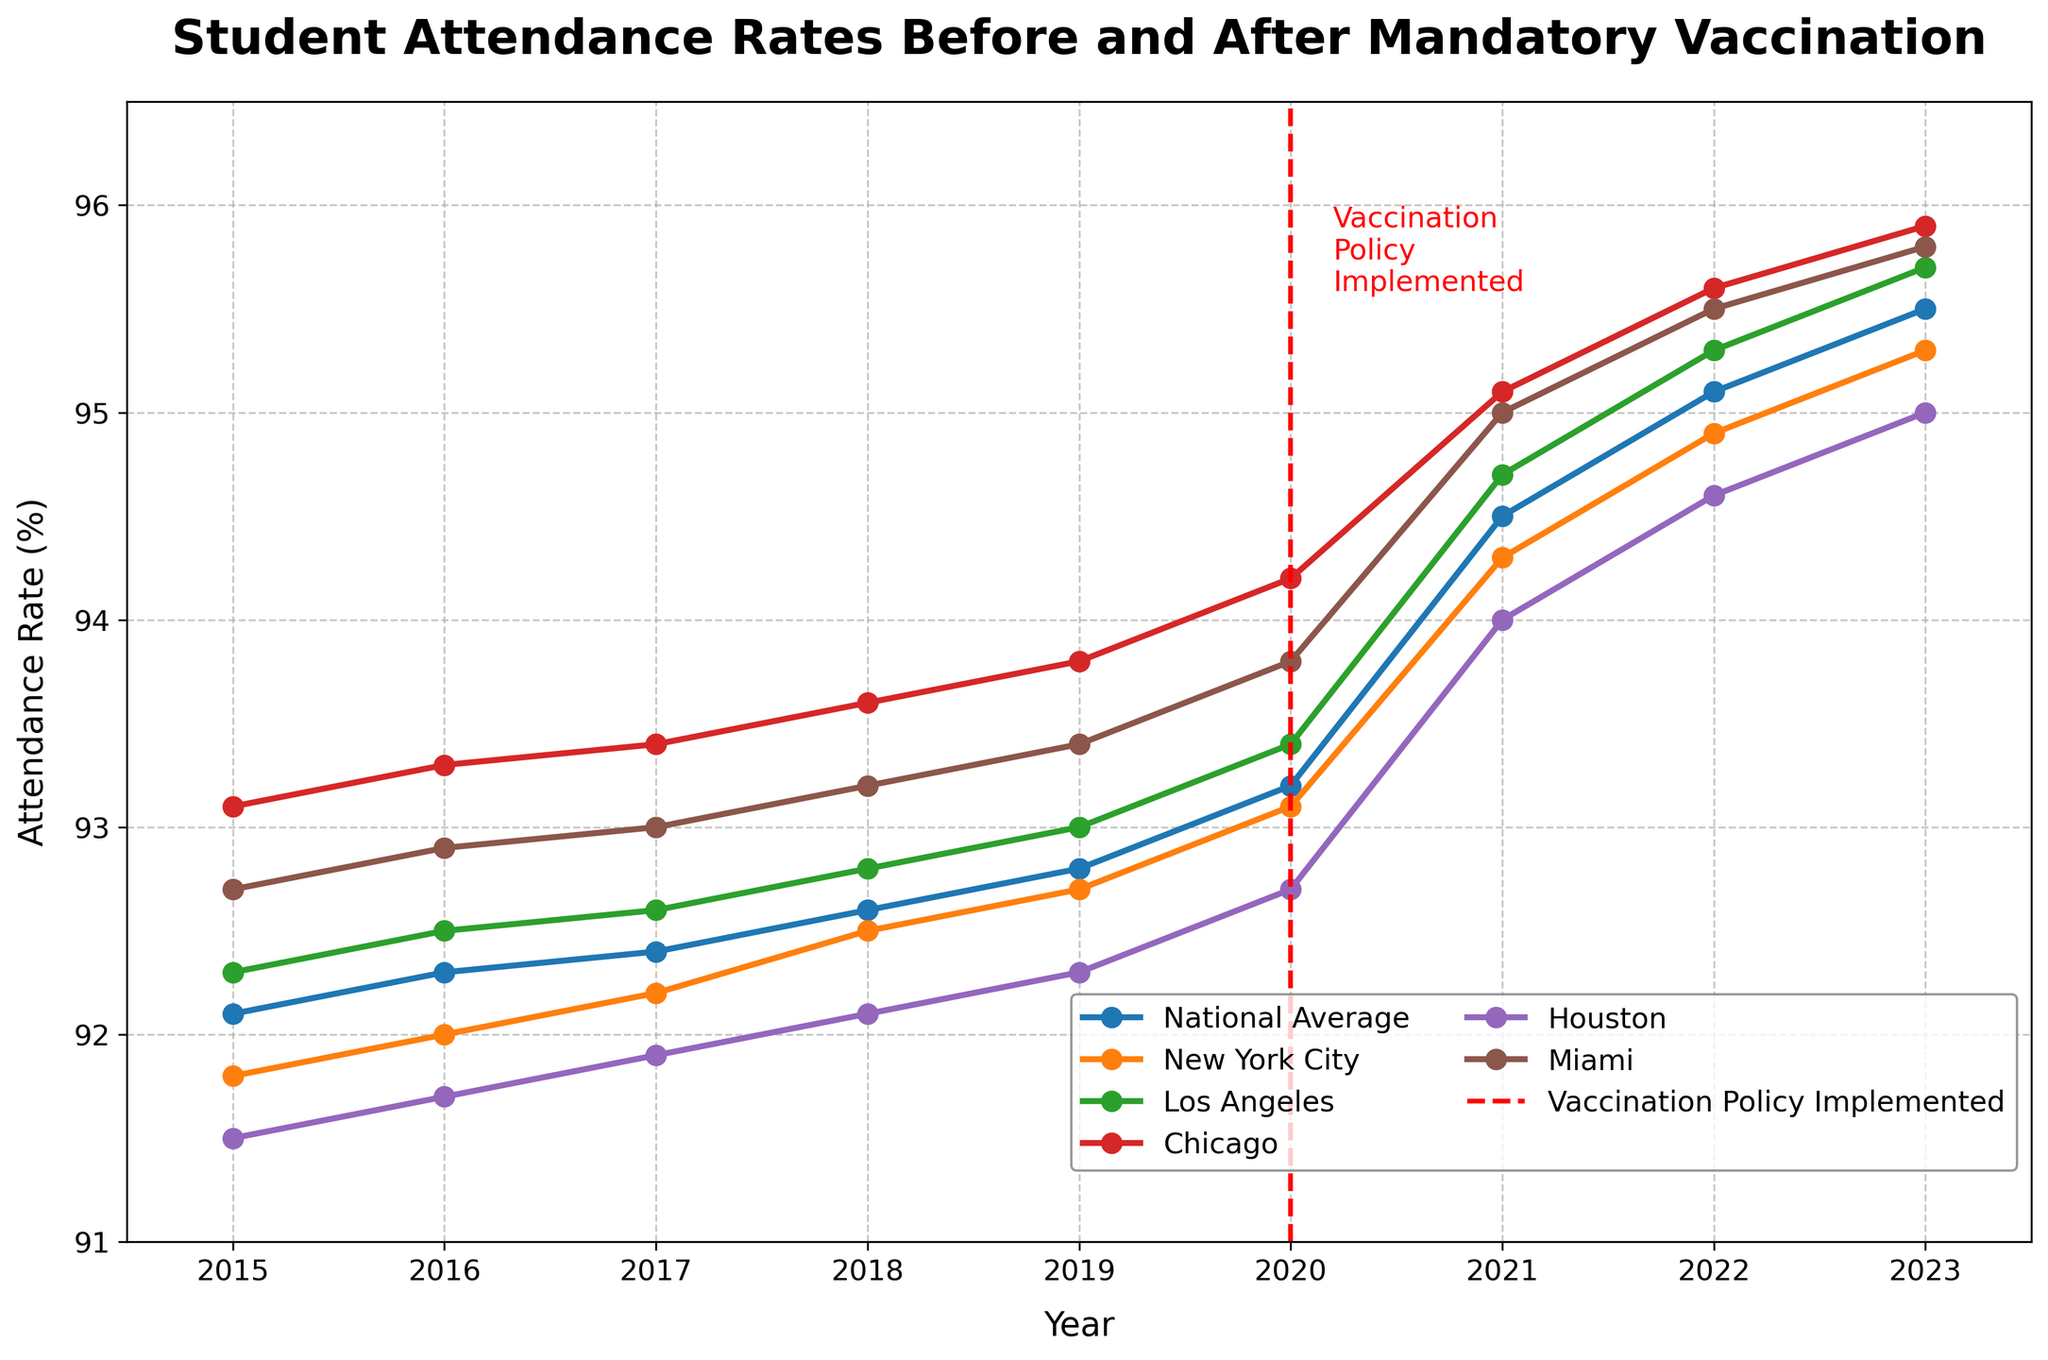What year was the vaccination policy implemented according to the figure? The figure shows a red dashed vertical line labeled "Vaccination Policy Implemented" at the year 2020, indicating that the policy was implemented in that year.
Answer: 2020 How did the national average attendance rate change from 2019 to 2021? The national average was 92.8% in 2019 and increased to 94.5% in 2021. The change is 94.5% - 92.8% = 1.7%.
Answer: Increased by 1.7% Which city had the highest attendance rate in 2023? By looking at the data points for 2023, Miami had the highest attendance rate at 95.8%.
Answer: Miami What was the average attendance rate for Houston from 2015 to 2019? The data for Houston from 2015 to 2019 is 91.5%, 91.7%, 91.9%, 92.1%, and 92.3%. The sum is 91.5 + 91.7 + 91.9 + 92.1 + 92.3 = 459.5. The average is 459.5 / 5 = 91.9%.
Answer: 91.9% Compare the attendance rates of New York City and Los Angeles in 2022. Which city had a higher rate, and by how much? New York City's attendance rate in 2022 was 94.9%, and Los Angeles' was 95.3%. Los Angeles had a higher rate by 95.3% - 94.9% = 0.4%.
Answer: Los Angeles by 0.4% What is the color used to represent the National Average line in the plot? The National Average line is represented in blue, which is indicated by the first color in the plotted lines.
Answer: Blue Which city showed the most significant increase in attendance rate immediately after the policy implementation in 2020? From 2020 to 2021, Chicago showed the most significant increase from 94.2% to 95.1%, which is an increase of 0.9%.
Answer: Chicago What is the attendance rate of Miami in the year the vaccination policy was implemented? According to the figure, the attendance rate of Miami in 2020 was 93.8%.
Answer: 93.8% By how much did the attendance rate of Los Angeles increase from 2015 to 2023? The attendance rate of Los Angeles was 92.3% in 2015 and 95.7% in 2023. The increase is 95.7% - 92.3% = 3.4%.
Answer: 3.4% What trend can be observed in the national average attendance rates from 2015 to 2023? The national average attendance rate shows a steady increase from 92.1% in 2015 to 95.5% in 2023, indicating a positive trend over these years.
Answer: Steady increase 